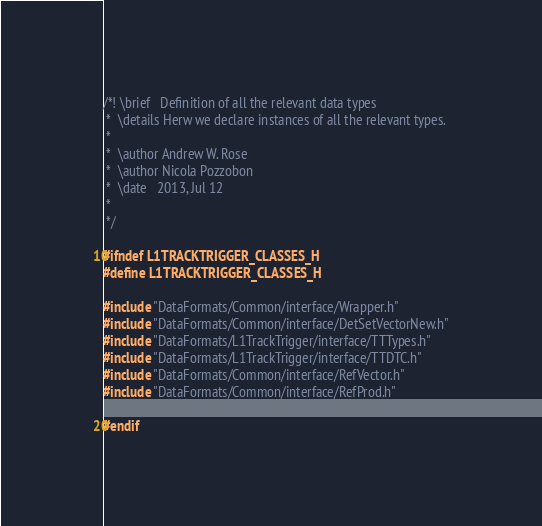<code> <loc_0><loc_0><loc_500><loc_500><_C_>/*! \brief   Definition of all the relevant data types
 *  \details Herw we declare instances of all the relevant types. 
 *
 *  \author Andrew W. Rose
 *  \author Nicola Pozzobon
 *  \date   2013, Jul 12
 *
 */

#ifndef L1TRACKTRIGGER_CLASSES_H
#define L1TRACKTRIGGER_CLASSES_H

#include "DataFormats/Common/interface/Wrapper.h"
#include "DataFormats/Common/interface/DetSetVectorNew.h"
#include "DataFormats/L1TrackTrigger/interface/TTTypes.h"
#include "DataFormats/L1TrackTrigger/interface/TTDTC.h"
#include "DataFormats/Common/interface/RefVector.h"
#include "DataFormats/Common/interface/RefProd.h"

#endif
</code> 